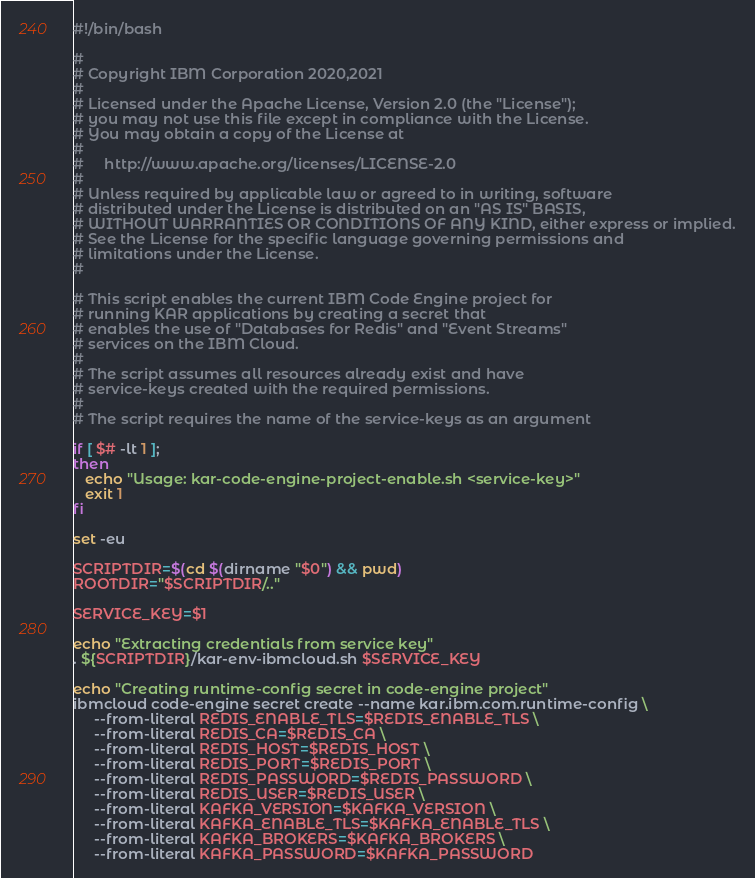<code> <loc_0><loc_0><loc_500><loc_500><_Bash_>#!/bin/bash

#
# Copyright IBM Corporation 2020,2021
#
# Licensed under the Apache License, Version 2.0 (the "License");
# you may not use this file except in compliance with the License.
# You may obtain a copy of the License at
#
#     http://www.apache.org/licenses/LICENSE-2.0
#
# Unless required by applicable law or agreed to in writing, software
# distributed under the License is distributed on an "AS IS" BASIS,
# WITHOUT WARRANTIES OR CONDITIONS OF ANY KIND, either express or implied.
# See the License for the specific language governing permissions and
# limitations under the License.
#

# This script enables the current IBM Code Engine project for
# running KAR applications by creating a secret that
# enables the use of "Databases for Redis" and "Event Streams"
# services on the IBM Cloud.
#
# The script assumes all resources already exist and have
# service-keys created with the required permissions.
#
# The script requires the name of the service-keys as an argument

if [ $# -lt 1 ];
then
   echo "Usage: kar-code-engine-project-enable.sh <service-key>"
   exit 1
fi

set -eu

SCRIPTDIR=$(cd $(dirname "$0") && pwd)
ROOTDIR="$SCRIPTDIR/.."

SERVICE_KEY=$1

echo "Extracting credentials from service key"
. ${SCRIPTDIR}/kar-env-ibmcloud.sh $SERVICE_KEY

echo "Creating runtime-config secret in code-engine project"
ibmcloud code-engine secret create --name kar.ibm.com.runtime-config \
     --from-literal REDIS_ENABLE_TLS=$REDIS_ENABLE_TLS \
     --from-literal REDIS_CA=$REDIS_CA \
     --from-literal REDIS_HOST=$REDIS_HOST \
     --from-literal REDIS_PORT=$REDIS_PORT \
     --from-literal REDIS_PASSWORD=$REDIS_PASSWORD \
     --from-literal REDIS_USER=$REDIS_USER \
     --from-literal KAFKA_VERSION=$KAFKA_VERSION \
     --from-literal KAFKA_ENABLE_TLS=$KAFKA_ENABLE_TLS \
     --from-literal KAFKA_BROKERS=$KAFKA_BROKERS \
     --from-literal KAFKA_PASSWORD=$KAFKA_PASSWORD
</code> 